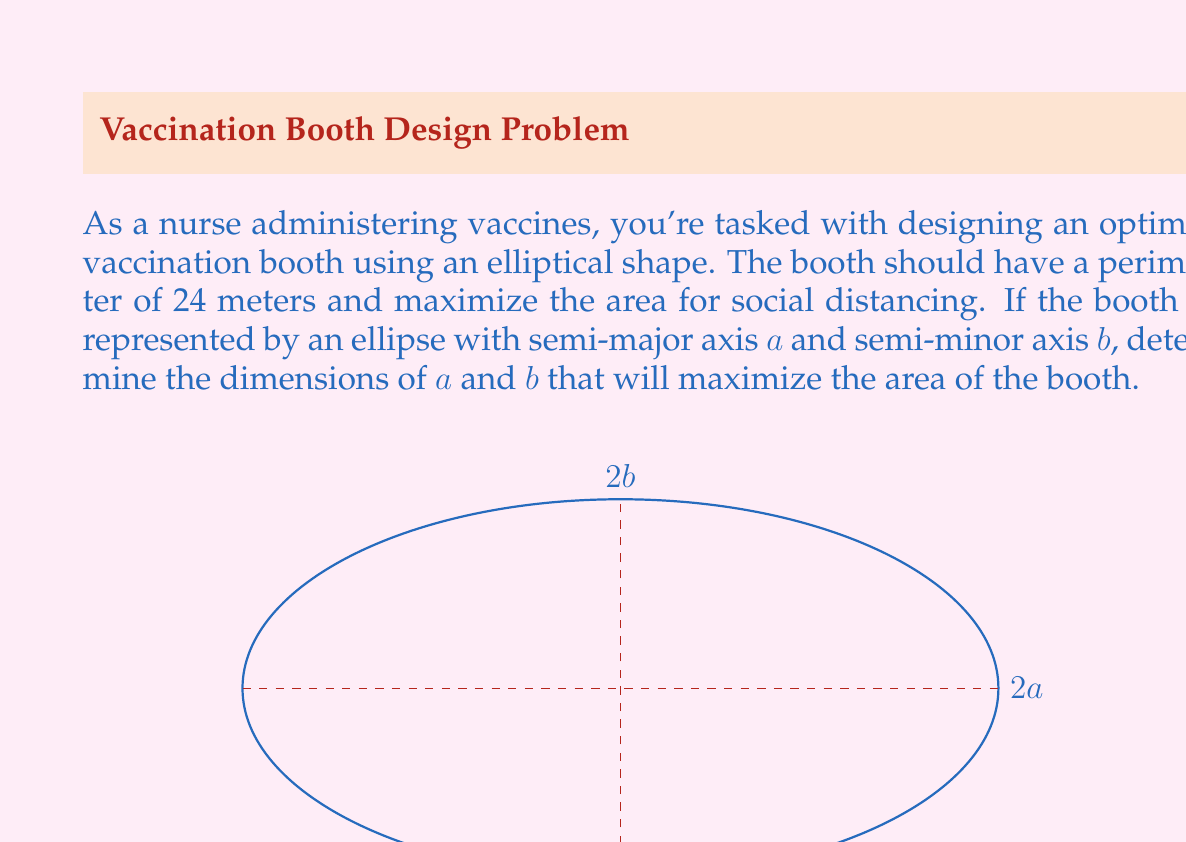Teach me how to tackle this problem. Let's approach this step-by-step:

1) The area of an ellipse is given by $A = \pi ab$.

2) The perimeter of an ellipse can be approximated by Ramanujan's formula:
   $P \approx \pi(3(a+b) - \sqrt{(3a+b)(a+3b)})$

3) We're given that the perimeter is 24 meters, so:
   $24 = \pi(3(a+b) - \sqrt{(3a+b)(a+3b)})$

4) To maximize the area, we need to express $b$ in terms of $a$ using the perimeter equation, then substitute this into the area formula and find the maximum.

5) Solving the perimeter equation for $b$ is complex, so we'll use a numerical approach.

6) We can create a function in terms of $a$:
   $f(a) = \pi a (\frac{24}{\pi} - 3a + \sqrt{(3a)^2 + (\frac{24}{\pi} - 3a)^2})$

7) Using calculus or a computational tool, we can find that this function reaches its maximum when $a \approx 4.8$ meters.

8) Substituting this back into the perimeter equation, we find $b \approx 2.4$ meters.

9) We can verify that these values satisfy the perimeter condition and maximize the area.
Answer: $a \approx 4.8$ meters, $b \approx 2.4$ meters 